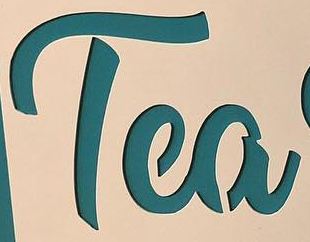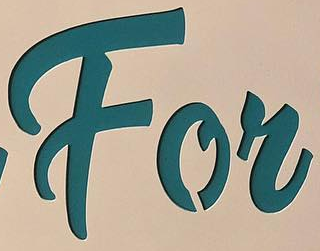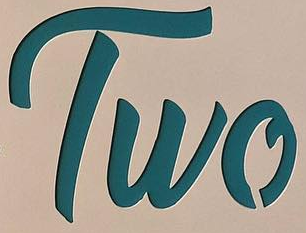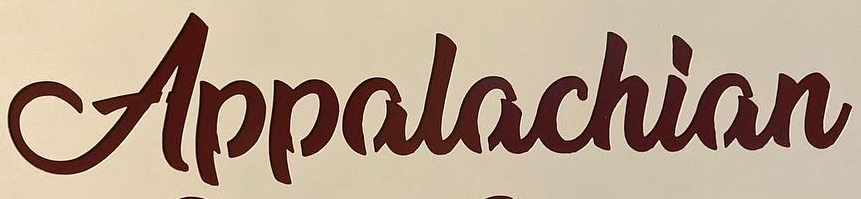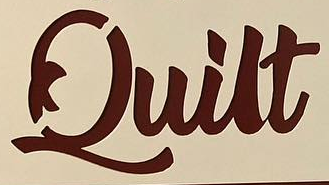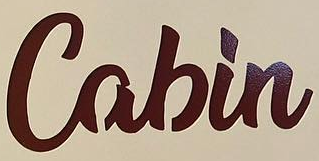What words are shown in these images in order, separated by a semicolon? Tea; For; Two; Appalachian; Quilt; Cabin 